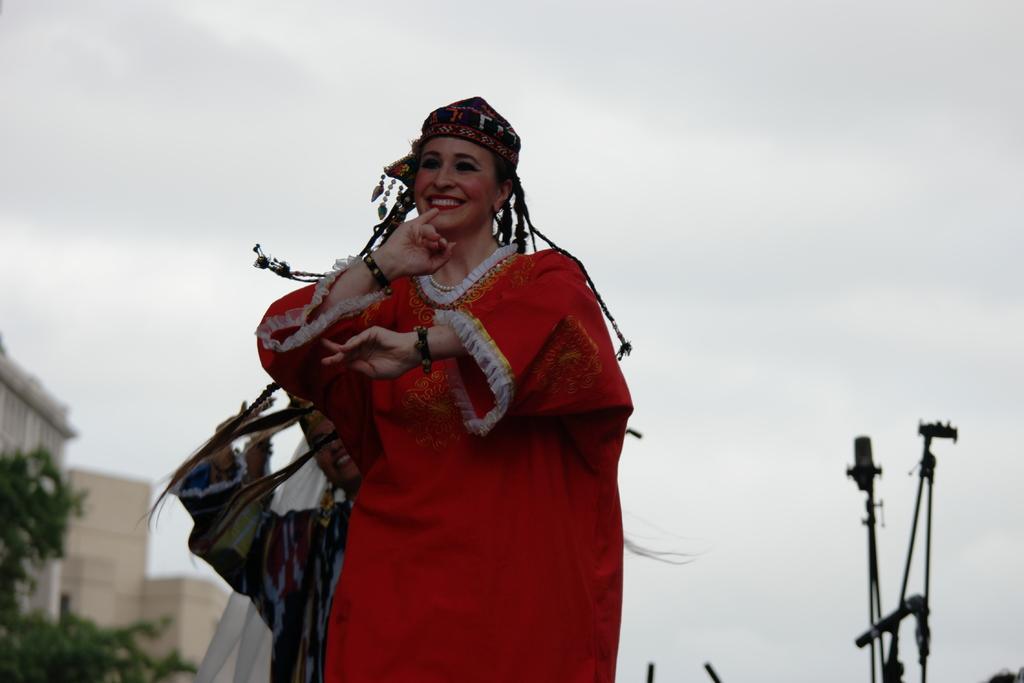Could you give a brief overview of what you see in this image? In the center of the image there is a person wearing a smile on her face. On the right side of the image there is some object. On the left side of the image there are buildings, trees and sky. 